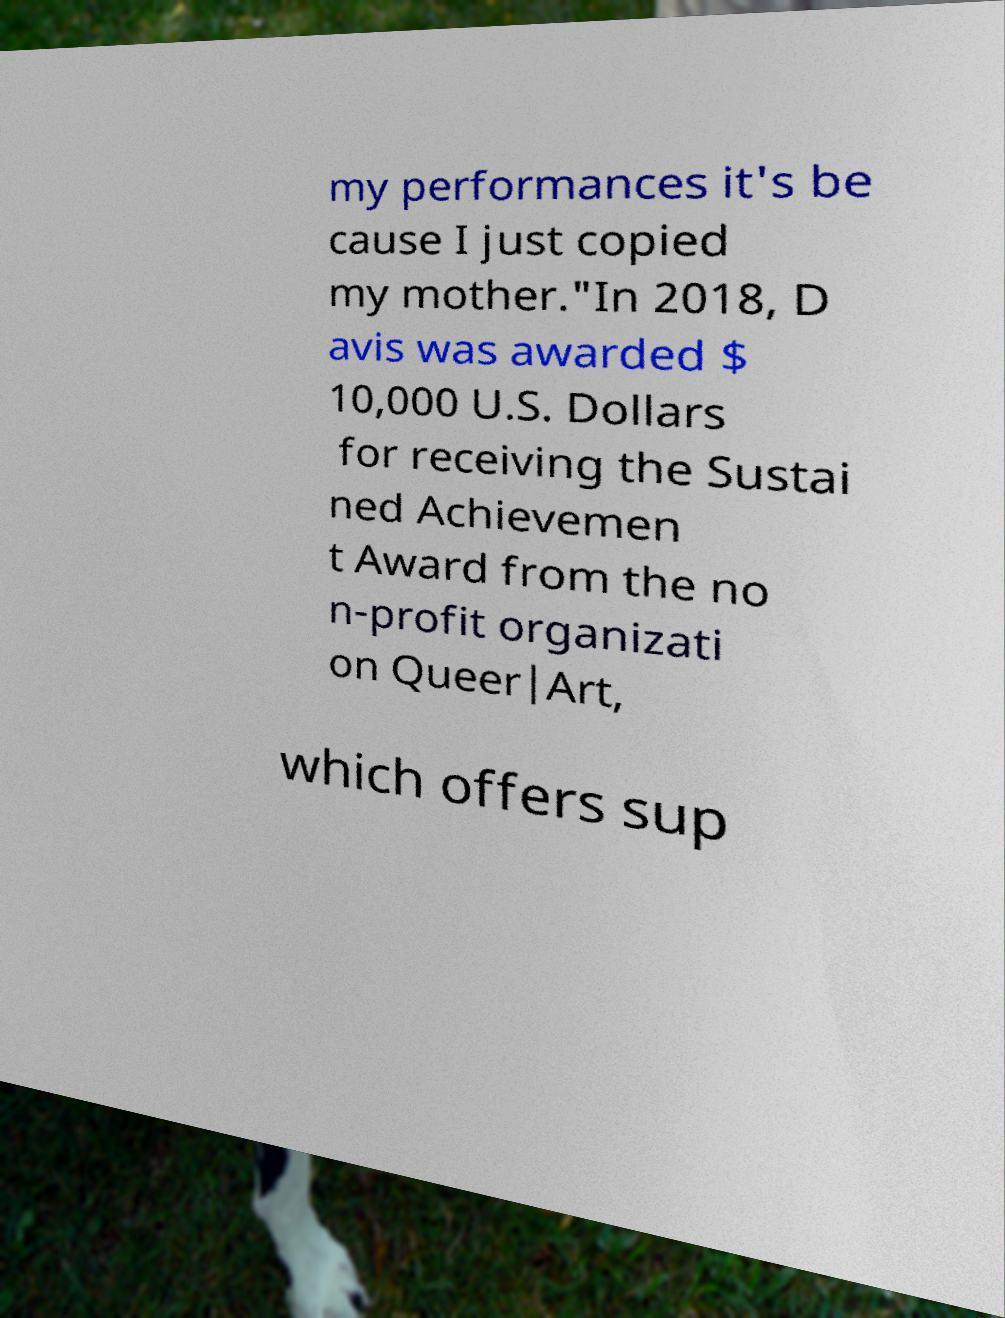I need the written content from this picture converted into text. Can you do that? my performances it's be cause I just copied my mother."In 2018, D avis was awarded $ 10,000 U.S. Dollars for receiving the Sustai ned Achievemen t Award from the no n-profit organizati on Queer|Art, which offers sup 